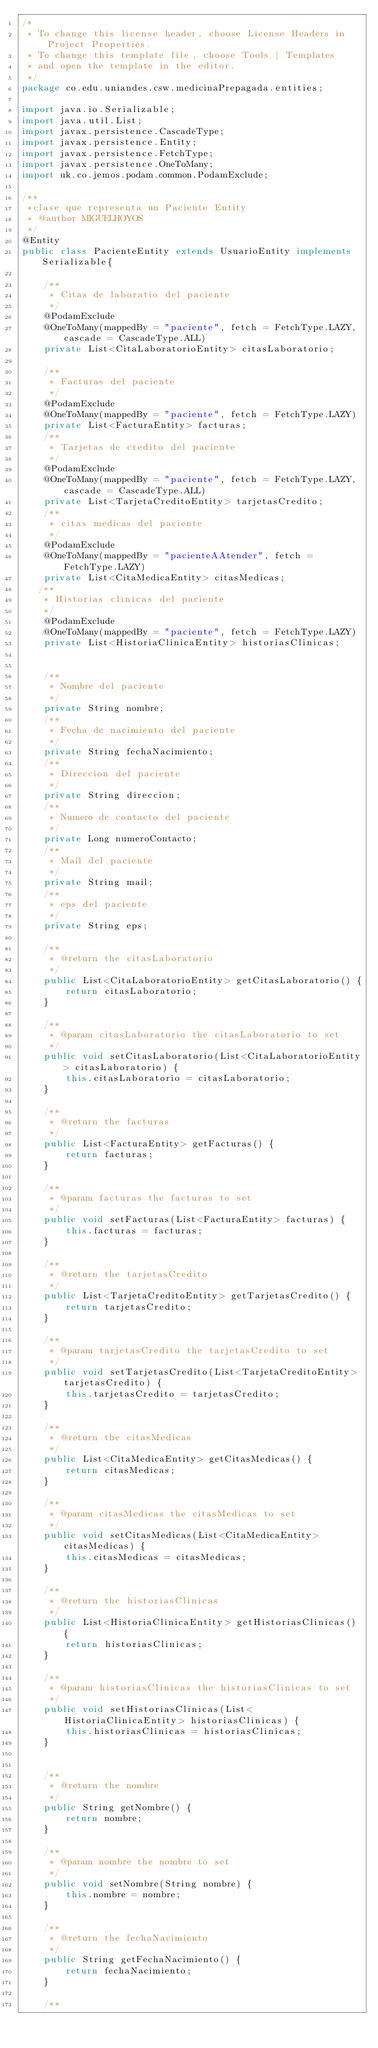Convert code to text. <code><loc_0><loc_0><loc_500><loc_500><_Java_>/*
 * To change this license header, choose License Headers in Project Properties.
 * To change this template file, choose Tools | Templates
 * and open the template in the editor.
 */
package co.edu.uniandes.csw.medicinaPrepagada.entities;

import java.io.Serializable;
import java.util.List;
import javax.persistence.CascadeType;
import javax.persistence.Entity;
import javax.persistence.FetchType;
import javax.persistence.OneToMany;
import uk.co.jemos.podam.common.PodamExclude;

/**
 *clase que representa un Paciente Entity
 * @author MIGUELHOYOS
 */
@Entity
public class PacienteEntity extends UsuarioEntity implements Serializable{
    
    /**
     * Citas de laboratio del paciente
     */
    @PodamExclude    
    @OneToMany(mappedBy = "paciente", fetch = FetchType.LAZY, cascade = CascadeType.ALL)
    private List<CitaLaboratorioEntity> citasLaboratorio;
    
    /**
     * Facturas del paciente
     */
    @PodamExclude  
    @OneToMany(mappedBy = "paciente", fetch = FetchType.LAZY)
    private List<FacturaEntity> facturas;
    /**
     * Tarjetas de credito del paciente
     */
    @PodamExclude
    @OneToMany(mappedBy = "paciente", fetch = FetchType.LAZY, cascade = CascadeType.ALL)
    private List<TarjetaCreditoEntity> tarjetasCredito;
    /**
     * citas medicas del paciente
     */
    @PodamExclude    
    @OneToMany(mappedBy = "pacienteAAtender", fetch = FetchType.LAZY)
    private List<CitaMedicaEntity> citasMedicas;
   /**
    * Historias clinicas del paciente
    */
    @PodamExclude    
    @OneToMany(mappedBy = "paciente", fetch = FetchType.LAZY)
    private List<HistoriaClinicaEntity> historiasClinicas;
 
    
    /**
     * Nombre del paciente
     */
    private String nombre;
    /**
     * Fecha de nacimiento del paciente
     */
    private String fechaNacimiento;
    /**
     * Direccion del paciente
     */
    private String direccion;
    /**
     * Numero de contacto del paciente
     */
    private Long numeroContacto;
    /**
     * Mail del paciente
     */
    private String mail;
    /**
     * eps del paciente
     */
    private String eps;

    /**
     * @return the citasLaboratorio
     */
    public List<CitaLaboratorioEntity> getCitasLaboratorio() {
        return citasLaboratorio;
    }

    /**
     * @param citasLaboratorio the citasLaboratorio to set
     */
    public void setCitasLaboratorio(List<CitaLaboratorioEntity> citasLaboratorio) {
        this.citasLaboratorio = citasLaboratorio;
    }

    /**
     * @return the facturas
     */
    public List<FacturaEntity> getFacturas() {
        return facturas;
    }

    /**
     * @param facturas the facturas to set
     */
    public void setFacturas(List<FacturaEntity> facturas) {
        this.facturas = facturas;
    }

    /**
     * @return the tarjetasCredito
     */
    public List<TarjetaCreditoEntity> getTarjetasCredito() {
        return tarjetasCredito;
    }

    /**
     * @param tarjetasCredito the tarjetasCredito to set
     */
    public void setTarjetasCredito(List<TarjetaCreditoEntity> tarjetasCredito) {
        this.tarjetasCredito = tarjetasCredito;
    }

    /**
     * @return the citasMedicas
     */
    public List<CitaMedicaEntity> getCitasMedicas() {
        return citasMedicas;
    }

    /**
     * @param citasMedicas the citasMedicas to set
     */
    public void setCitasMedicas(List<CitaMedicaEntity> citasMedicas) {
        this.citasMedicas = citasMedicas;
    }

    /**
     * @return the historiasClinicas
     */
    public List<HistoriaClinicaEntity> getHistoriasClinicas() {
        return historiasClinicas;
    }

    /**
     * @param historiasClinicas the historiasClinicas to set
     */
    public void setHistoriasClinicas(List<HistoriaClinicaEntity> historiasClinicas) {
        this.historiasClinicas = historiasClinicas;
    }


    /**
     * @return the nombre
     */
    public String getNombre() {
        return nombre;
    }

    /**
     * @param nombre the nombre to set
     */
    public void setNombre(String nombre) {
        this.nombre = nombre;
    }

    /**
     * @return the fechaNacimiento
     */
    public String getFechaNacimiento() {
        return fechaNacimiento;
    }

    /**</code> 